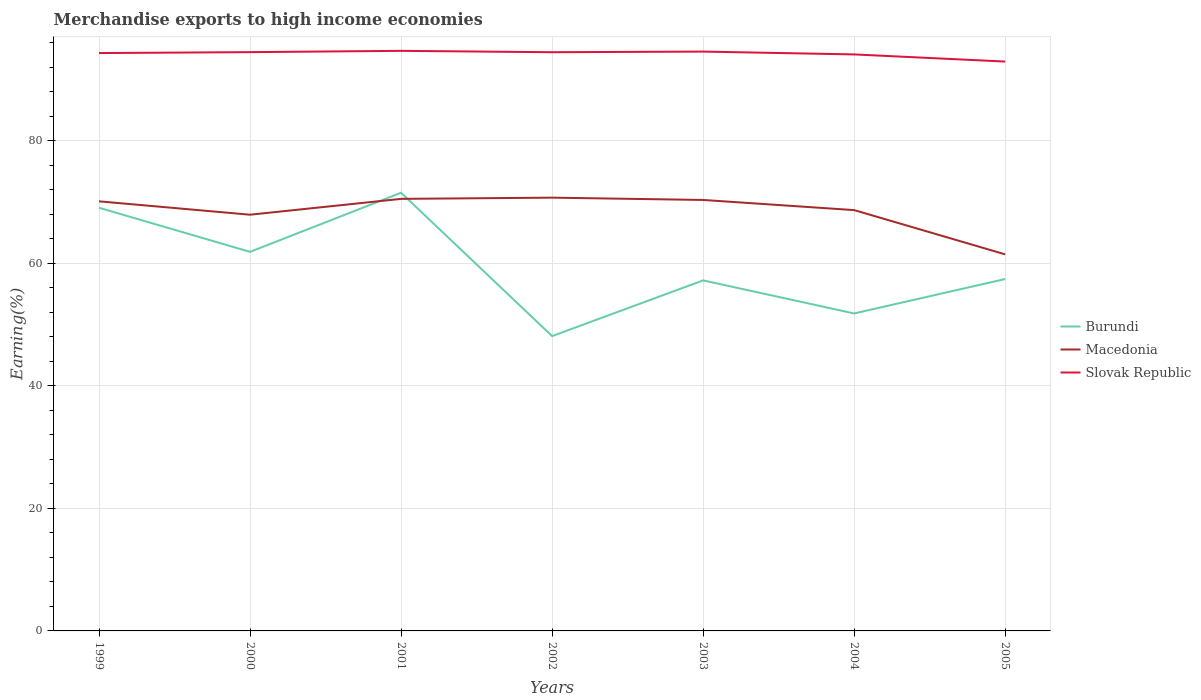Across all years, what is the maximum percentage of amount earned from merchandise exports in Macedonia?
Your answer should be very brief. 61.48. In which year was the percentage of amount earned from merchandise exports in Slovak Republic maximum?
Provide a short and direct response. 2005. What is the total percentage of amount earned from merchandise exports in Macedonia in the graph?
Offer a terse response. 1.43. What is the difference between the highest and the second highest percentage of amount earned from merchandise exports in Macedonia?
Keep it short and to the point. 9.26. What is the difference between two consecutive major ticks on the Y-axis?
Offer a terse response. 20. Does the graph contain grids?
Offer a terse response. Yes. How are the legend labels stacked?
Keep it short and to the point. Vertical. What is the title of the graph?
Give a very brief answer. Merchandise exports to high income economies. Does "Argentina" appear as one of the legend labels in the graph?
Make the answer very short. No. What is the label or title of the Y-axis?
Offer a very short reply. Earning(%). What is the Earning(%) in Burundi in 1999?
Offer a terse response. 69.09. What is the Earning(%) of Macedonia in 1999?
Ensure brevity in your answer.  70.14. What is the Earning(%) in Slovak Republic in 1999?
Make the answer very short. 94.35. What is the Earning(%) in Burundi in 2000?
Provide a succinct answer. 61.89. What is the Earning(%) of Macedonia in 2000?
Provide a succinct answer. 67.95. What is the Earning(%) of Slovak Republic in 2000?
Offer a terse response. 94.5. What is the Earning(%) of Burundi in 2001?
Provide a succinct answer. 71.54. What is the Earning(%) in Macedonia in 2001?
Make the answer very short. 70.54. What is the Earning(%) in Slovak Republic in 2001?
Make the answer very short. 94.71. What is the Earning(%) in Burundi in 2002?
Ensure brevity in your answer.  48.14. What is the Earning(%) in Macedonia in 2002?
Your response must be concise. 70.74. What is the Earning(%) in Slovak Republic in 2002?
Offer a very short reply. 94.48. What is the Earning(%) in Burundi in 2003?
Your answer should be very brief. 57.23. What is the Earning(%) of Macedonia in 2003?
Keep it short and to the point. 70.36. What is the Earning(%) of Slovak Republic in 2003?
Your answer should be very brief. 94.59. What is the Earning(%) of Burundi in 2004?
Your answer should be very brief. 51.83. What is the Earning(%) of Macedonia in 2004?
Ensure brevity in your answer.  68.71. What is the Earning(%) in Slovak Republic in 2004?
Give a very brief answer. 94.12. What is the Earning(%) of Burundi in 2005?
Offer a very short reply. 57.45. What is the Earning(%) of Macedonia in 2005?
Your response must be concise. 61.48. What is the Earning(%) in Slovak Republic in 2005?
Your answer should be very brief. 92.96. Across all years, what is the maximum Earning(%) of Burundi?
Keep it short and to the point. 71.54. Across all years, what is the maximum Earning(%) in Macedonia?
Keep it short and to the point. 70.74. Across all years, what is the maximum Earning(%) in Slovak Republic?
Your answer should be compact. 94.71. Across all years, what is the minimum Earning(%) of Burundi?
Offer a very short reply. 48.14. Across all years, what is the minimum Earning(%) of Macedonia?
Your answer should be compact. 61.48. Across all years, what is the minimum Earning(%) in Slovak Republic?
Your answer should be very brief. 92.96. What is the total Earning(%) in Burundi in the graph?
Provide a succinct answer. 417.17. What is the total Earning(%) in Macedonia in the graph?
Provide a short and direct response. 479.92. What is the total Earning(%) of Slovak Republic in the graph?
Your answer should be compact. 659.71. What is the difference between the Earning(%) of Burundi in 1999 and that in 2000?
Your answer should be very brief. 7.2. What is the difference between the Earning(%) in Macedonia in 1999 and that in 2000?
Your response must be concise. 2.19. What is the difference between the Earning(%) in Slovak Republic in 1999 and that in 2000?
Ensure brevity in your answer.  -0.15. What is the difference between the Earning(%) of Burundi in 1999 and that in 2001?
Your answer should be very brief. -2.45. What is the difference between the Earning(%) of Macedonia in 1999 and that in 2001?
Give a very brief answer. -0.4. What is the difference between the Earning(%) of Slovak Republic in 1999 and that in 2001?
Make the answer very short. -0.36. What is the difference between the Earning(%) of Burundi in 1999 and that in 2002?
Your answer should be very brief. 20.95. What is the difference between the Earning(%) in Macedonia in 1999 and that in 2002?
Provide a succinct answer. -0.6. What is the difference between the Earning(%) of Slovak Republic in 1999 and that in 2002?
Offer a very short reply. -0.14. What is the difference between the Earning(%) in Burundi in 1999 and that in 2003?
Give a very brief answer. 11.86. What is the difference between the Earning(%) of Macedonia in 1999 and that in 2003?
Provide a short and direct response. -0.22. What is the difference between the Earning(%) in Slovak Republic in 1999 and that in 2003?
Provide a succinct answer. -0.24. What is the difference between the Earning(%) of Burundi in 1999 and that in 2004?
Ensure brevity in your answer.  17.26. What is the difference between the Earning(%) of Macedonia in 1999 and that in 2004?
Offer a terse response. 1.43. What is the difference between the Earning(%) of Slovak Republic in 1999 and that in 2004?
Give a very brief answer. 0.22. What is the difference between the Earning(%) of Burundi in 1999 and that in 2005?
Offer a very short reply. 11.64. What is the difference between the Earning(%) of Macedonia in 1999 and that in 2005?
Provide a short and direct response. 8.66. What is the difference between the Earning(%) of Slovak Republic in 1999 and that in 2005?
Your answer should be compact. 1.39. What is the difference between the Earning(%) of Burundi in 2000 and that in 2001?
Your response must be concise. -9.65. What is the difference between the Earning(%) of Macedonia in 2000 and that in 2001?
Provide a succinct answer. -2.59. What is the difference between the Earning(%) in Slovak Republic in 2000 and that in 2001?
Your answer should be very brief. -0.21. What is the difference between the Earning(%) of Burundi in 2000 and that in 2002?
Provide a short and direct response. 13.76. What is the difference between the Earning(%) of Macedonia in 2000 and that in 2002?
Provide a short and direct response. -2.78. What is the difference between the Earning(%) in Slovak Republic in 2000 and that in 2002?
Give a very brief answer. 0.01. What is the difference between the Earning(%) in Burundi in 2000 and that in 2003?
Provide a short and direct response. 4.66. What is the difference between the Earning(%) in Macedonia in 2000 and that in 2003?
Offer a very short reply. -2.41. What is the difference between the Earning(%) of Slovak Republic in 2000 and that in 2003?
Make the answer very short. -0.09. What is the difference between the Earning(%) of Burundi in 2000 and that in 2004?
Your response must be concise. 10.06. What is the difference between the Earning(%) in Macedonia in 2000 and that in 2004?
Keep it short and to the point. -0.75. What is the difference between the Earning(%) in Slovak Republic in 2000 and that in 2004?
Keep it short and to the point. 0.37. What is the difference between the Earning(%) in Burundi in 2000 and that in 2005?
Your response must be concise. 4.44. What is the difference between the Earning(%) in Macedonia in 2000 and that in 2005?
Your answer should be very brief. 6.48. What is the difference between the Earning(%) in Slovak Republic in 2000 and that in 2005?
Provide a succinct answer. 1.54. What is the difference between the Earning(%) in Burundi in 2001 and that in 2002?
Give a very brief answer. 23.4. What is the difference between the Earning(%) of Macedonia in 2001 and that in 2002?
Offer a very short reply. -0.2. What is the difference between the Earning(%) in Slovak Republic in 2001 and that in 2002?
Your response must be concise. 0.23. What is the difference between the Earning(%) of Burundi in 2001 and that in 2003?
Keep it short and to the point. 14.31. What is the difference between the Earning(%) in Macedonia in 2001 and that in 2003?
Offer a very short reply. 0.18. What is the difference between the Earning(%) of Slovak Republic in 2001 and that in 2003?
Your response must be concise. 0.12. What is the difference between the Earning(%) of Burundi in 2001 and that in 2004?
Make the answer very short. 19.7. What is the difference between the Earning(%) in Macedonia in 2001 and that in 2004?
Give a very brief answer. 1.84. What is the difference between the Earning(%) in Slovak Republic in 2001 and that in 2004?
Provide a short and direct response. 0.59. What is the difference between the Earning(%) in Burundi in 2001 and that in 2005?
Provide a succinct answer. 14.08. What is the difference between the Earning(%) of Macedonia in 2001 and that in 2005?
Ensure brevity in your answer.  9.06. What is the difference between the Earning(%) in Slovak Republic in 2001 and that in 2005?
Give a very brief answer. 1.75. What is the difference between the Earning(%) in Burundi in 2002 and that in 2003?
Your answer should be compact. -9.09. What is the difference between the Earning(%) of Macedonia in 2002 and that in 2003?
Ensure brevity in your answer.  0.38. What is the difference between the Earning(%) of Slovak Republic in 2002 and that in 2003?
Provide a short and direct response. -0.1. What is the difference between the Earning(%) in Burundi in 2002 and that in 2004?
Offer a terse response. -3.7. What is the difference between the Earning(%) of Macedonia in 2002 and that in 2004?
Offer a terse response. 2.03. What is the difference between the Earning(%) of Slovak Republic in 2002 and that in 2004?
Offer a very short reply. 0.36. What is the difference between the Earning(%) of Burundi in 2002 and that in 2005?
Your response must be concise. -9.32. What is the difference between the Earning(%) of Macedonia in 2002 and that in 2005?
Offer a terse response. 9.26. What is the difference between the Earning(%) of Slovak Republic in 2002 and that in 2005?
Provide a succinct answer. 1.53. What is the difference between the Earning(%) in Burundi in 2003 and that in 2004?
Make the answer very short. 5.4. What is the difference between the Earning(%) in Macedonia in 2003 and that in 2004?
Provide a succinct answer. 1.66. What is the difference between the Earning(%) of Slovak Republic in 2003 and that in 2004?
Offer a very short reply. 0.46. What is the difference between the Earning(%) of Burundi in 2003 and that in 2005?
Provide a succinct answer. -0.22. What is the difference between the Earning(%) of Macedonia in 2003 and that in 2005?
Provide a succinct answer. 8.88. What is the difference between the Earning(%) in Slovak Republic in 2003 and that in 2005?
Ensure brevity in your answer.  1.63. What is the difference between the Earning(%) of Burundi in 2004 and that in 2005?
Offer a terse response. -5.62. What is the difference between the Earning(%) in Macedonia in 2004 and that in 2005?
Your answer should be very brief. 7.23. What is the difference between the Earning(%) of Slovak Republic in 2004 and that in 2005?
Ensure brevity in your answer.  1.17. What is the difference between the Earning(%) of Burundi in 1999 and the Earning(%) of Macedonia in 2000?
Provide a short and direct response. 1.14. What is the difference between the Earning(%) in Burundi in 1999 and the Earning(%) in Slovak Republic in 2000?
Offer a terse response. -25.41. What is the difference between the Earning(%) of Macedonia in 1999 and the Earning(%) of Slovak Republic in 2000?
Ensure brevity in your answer.  -24.36. What is the difference between the Earning(%) in Burundi in 1999 and the Earning(%) in Macedonia in 2001?
Make the answer very short. -1.45. What is the difference between the Earning(%) of Burundi in 1999 and the Earning(%) of Slovak Republic in 2001?
Offer a terse response. -25.62. What is the difference between the Earning(%) of Macedonia in 1999 and the Earning(%) of Slovak Republic in 2001?
Keep it short and to the point. -24.57. What is the difference between the Earning(%) of Burundi in 1999 and the Earning(%) of Macedonia in 2002?
Ensure brevity in your answer.  -1.65. What is the difference between the Earning(%) in Burundi in 1999 and the Earning(%) in Slovak Republic in 2002?
Give a very brief answer. -25.39. What is the difference between the Earning(%) of Macedonia in 1999 and the Earning(%) of Slovak Republic in 2002?
Your answer should be compact. -24.34. What is the difference between the Earning(%) in Burundi in 1999 and the Earning(%) in Macedonia in 2003?
Your response must be concise. -1.27. What is the difference between the Earning(%) in Burundi in 1999 and the Earning(%) in Slovak Republic in 2003?
Offer a very short reply. -25.5. What is the difference between the Earning(%) of Macedonia in 1999 and the Earning(%) of Slovak Republic in 2003?
Keep it short and to the point. -24.45. What is the difference between the Earning(%) of Burundi in 1999 and the Earning(%) of Macedonia in 2004?
Offer a terse response. 0.38. What is the difference between the Earning(%) of Burundi in 1999 and the Earning(%) of Slovak Republic in 2004?
Provide a succinct answer. -25.03. What is the difference between the Earning(%) in Macedonia in 1999 and the Earning(%) in Slovak Republic in 2004?
Your answer should be compact. -23.98. What is the difference between the Earning(%) in Burundi in 1999 and the Earning(%) in Macedonia in 2005?
Offer a terse response. 7.61. What is the difference between the Earning(%) in Burundi in 1999 and the Earning(%) in Slovak Republic in 2005?
Make the answer very short. -23.87. What is the difference between the Earning(%) of Macedonia in 1999 and the Earning(%) of Slovak Republic in 2005?
Provide a succinct answer. -22.82. What is the difference between the Earning(%) of Burundi in 2000 and the Earning(%) of Macedonia in 2001?
Give a very brief answer. -8.65. What is the difference between the Earning(%) of Burundi in 2000 and the Earning(%) of Slovak Republic in 2001?
Your answer should be compact. -32.82. What is the difference between the Earning(%) of Macedonia in 2000 and the Earning(%) of Slovak Republic in 2001?
Offer a terse response. -26.75. What is the difference between the Earning(%) of Burundi in 2000 and the Earning(%) of Macedonia in 2002?
Ensure brevity in your answer.  -8.85. What is the difference between the Earning(%) of Burundi in 2000 and the Earning(%) of Slovak Republic in 2002?
Your answer should be very brief. -32.59. What is the difference between the Earning(%) in Macedonia in 2000 and the Earning(%) in Slovak Republic in 2002?
Ensure brevity in your answer.  -26.53. What is the difference between the Earning(%) of Burundi in 2000 and the Earning(%) of Macedonia in 2003?
Make the answer very short. -8.47. What is the difference between the Earning(%) in Burundi in 2000 and the Earning(%) in Slovak Republic in 2003?
Your answer should be compact. -32.7. What is the difference between the Earning(%) in Macedonia in 2000 and the Earning(%) in Slovak Republic in 2003?
Make the answer very short. -26.63. What is the difference between the Earning(%) of Burundi in 2000 and the Earning(%) of Macedonia in 2004?
Offer a very short reply. -6.82. What is the difference between the Earning(%) in Burundi in 2000 and the Earning(%) in Slovak Republic in 2004?
Ensure brevity in your answer.  -32.23. What is the difference between the Earning(%) of Macedonia in 2000 and the Earning(%) of Slovak Republic in 2004?
Your answer should be compact. -26.17. What is the difference between the Earning(%) of Burundi in 2000 and the Earning(%) of Macedonia in 2005?
Offer a very short reply. 0.41. What is the difference between the Earning(%) of Burundi in 2000 and the Earning(%) of Slovak Republic in 2005?
Ensure brevity in your answer.  -31.07. What is the difference between the Earning(%) in Macedonia in 2000 and the Earning(%) in Slovak Republic in 2005?
Your response must be concise. -25. What is the difference between the Earning(%) in Burundi in 2001 and the Earning(%) in Macedonia in 2002?
Offer a terse response. 0.8. What is the difference between the Earning(%) in Burundi in 2001 and the Earning(%) in Slovak Republic in 2002?
Provide a short and direct response. -22.95. What is the difference between the Earning(%) of Macedonia in 2001 and the Earning(%) of Slovak Republic in 2002?
Your response must be concise. -23.94. What is the difference between the Earning(%) in Burundi in 2001 and the Earning(%) in Macedonia in 2003?
Your answer should be compact. 1.17. What is the difference between the Earning(%) in Burundi in 2001 and the Earning(%) in Slovak Republic in 2003?
Ensure brevity in your answer.  -23.05. What is the difference between the Earning(%) of Macedonia in 2001 and the Earning(%) of Slovak Republic in 2003?
Keep it short and to the point. -24.05. What is the difference between the Earning(%) of Burundi in 2001 and the Earning(%) of Macedonia in 2004?
Offer a terse response. 2.83. What is the difference between the Earning(%) of Burundi in 2001 and the Earning(%) of Slovak Republic in 2004?
Your response must be concise. -22.59. What is the difference between the Earning(%) in Macedonia in 2001 and the Earning(%) in Slovak Republic in 2004?
Your answer should be very brief. -23.58. What is the difference between the Earning(%) in Burundi in 2001 and the Earning(%) in Macedonia in 2005?
Keep it short and to the point. 10.06. What is the difference between the Earning(%) of Burundi in 2001 and the Earning(%) of Slovak Republic in 2005?
Provide a short and direct response. -21.42. What is the difference between the Earning(%) of Macedonia in 2001 and the Earning(%) of Slovak Republic in 2005?
Provide a succinct answer. -22.42. What is the difference between the Earning(%) in Burundi in 2002 and the Earning(%) in Macedonia in 2003?
Offer a very short reply. -22.23. What is the difference between the Earning(%) in Burundi in 2002 and the Earning(%) in Slovak Republic in 2003?
Give a very brief answer. -46.45. What is the difference between the Earning(%) of Macedonia in 2002 and the Earning(%) of Slovak Republic in 2003?
Your answer should be compact. -23.85. What is the difference between the Earning(%) of Burundi in 2002 and the Earning(%) of Macedonia in 2004?
Provide a short and direct response. -20.57. What is the difference between the Earning(%) of Burundi in 2002 and the Earning(%) of Slovak Republic in 2004?
Your response must be concise. -45.99. What is the difference between the Earning(%) of Macedonia in 2002 and the Earning(%) of Slovak Republic in 2004?
Your response must be concise. -23.39. What is the difference between the Earning(%) in Burundi in 2002 and the Earning(%) in Macedonia in 2005?
Make the answer very short. -13.34. What is the difference between the Earning(%) in Burundi in 2002 and the Earning(%) in Slovak Republic in 2005?
Offer a very short reply. -44.82. What is the difference between the Earning(%) in Macedonia in 2002 and the Earning(%) in Slovak Republic in 2005?
Offer a terse response. -22.22. What is the difference between the Earning(%) of Burundi in 2003 and the Earning(%) of Macedonia in 2004?
Keep it short and to the point. -11.48. What is the difference between the Earning(%) of Burundi in 2003 and the Earning(%) of Slovak Republic in 2004?
Give a very brief answer. -36.89. What is the difference between the Earning(%) of Macedonia in 2003 and the Earning(%) of Slovak Republic in 2004?
Provide a short and direct response. -23.76. What is the difference between the Earning(%) of Burundi in 2003 and the Earning(%) of Macedonia in 2005?
Provide a succinct answer. -4.25. What is the difference between the Earning(%) in Burundi in 2003 and the Earning(%) in Slovak Republic in 2005?
Provide a short and direct response. -35.73. What is the difference between the Earning(%) in Macedonia in 2003 and the Earning(%) in Slovak Republic in 2005?
Make the answer very short. -22.59. What is the difference between the Earning(%) in Burundi in 2004 and the Earning(%) in Macedonia in 2005?
Offer a terse response. -9.65. What is the difference between the Earning(%) in Burundi in 2004 and the Earning(%) in Slovak Republic in 2005?
Offer a terse response. -41.13. What is the difference between the Earning(%) in Macedonia in 2004 and the Earning(%) in Slovak Republic in 2005?
Give a very brief answer. -24.25. What is the average Earning(%) in Burundi per year?
Provide a short and direct response. 59.6. What is the average Earning(%) in Macedonia per year?
Your answer should be very brief. 68.56. What is the average Earning(%) of Slovak Republic per year?
Make the answer very short. 94.24. In the year 1999, what is the difference between the Earning(%) of Burundi and Earning(%) of Macedonia?
Provide a succinct answer. -1.05. In the year 1999, what is the difference between the Earning(%) in Burundi and Earning(%) in Slovak Republic?
Offer a terse response. -25.25. In the year 1999, what is the difference between the Earning(%) of Macedonia and Earning(%) of Slovak Republic?
Provide a succinct answer. -24.21. In the year 2000, what is the difference between the Earning(%) in Burundi and Earning(%) in Macedonia?
Ensure brevity in your answer.  -6.06. In the year 2000, what is the difference between the Earning(%) in Burundi and Earning(%) in Slovak Republic?
Your response must be concise. -32.61. In the year 2000, what is the difference between the Earning(%) of Macedonia and Earning(%) of Slovak Republic?
Provide a succinct answer. -26.54. In the year 2001, what is the difference between the Earning(%) of Burundi and Earning(%) of Slovak Republic?
Your answer should be compact. -23.17. In the year 2001, what is the difference between the Earning(%) of Macedonia and Earning(%) of Slovak Republic?
Ensure brevity in your answer.  -24.17. In the year 2002, what is the difference between the Earning(%) of Burundi and Earning(%) of Macedonia?
Provide a short and direct response. -22.6. In the year 2002, what is the difference between the Earning(%) in Burundi and Earning(%) in Slovak Republic?
Provide a succinct answer. -46.35. In the year 2002, what is the difference between the Earning(%) of Macedonia and Earning(%) of Slovak Republic?
Make the answer very short. -23.75. In the year 2003, what is the difference between the Earning(%) in Burundi and Earning(%) in Macedonia?
Make the answer very short. -13.13. In the year 2003, what is the difference between the Earning(%) of Burundi and Earning(%) of Slovak Republic?
Provide a succinct answer. -37.36. In the year 2003, what is the difference between the Earning(%) in Macedonia and Earning(%) in Slovak Republic?
Ensure brevity in your answer.  -24.22. In the year 2004, what is the difference between the Earning(%) in Burundi and Earning(%) in Macedonia?
Provide a succinct answer. -16.87. In the year 2004, what is the difference between the Earning(%) of Burundi and Earning(%) of Slovak Republic?
Provide a short and direct response. -42.29. In the year 2004, what is the difference between the Earning(%) of Macedonia and Earning(%) of Slovak Republic?
Offer a terse response. -25.42. In the year 2005, what is the difference between the Earning(%) in Burundi and Earning(%) in Macedonia?
Ensure brevity in your answer.  -4.02. In the year 2005, what is the difference between the Earning(%) of Burundi and Earning(%) of Slovak Republic?
Provide a short and direct response. -35.5. In the year 2005, what is the difference between the Earning(%) in Macedonia and Earning(%) in Slovak Republic?
Your answer should be compact. -31.48. What is the ratio of the Earning(%) in Burundi in 1999 to that in 2000?
Your answer should be compact. 1.12. What is the ratio of the Earning(%) of Macedonia in 1999 to that in 2000?
Provide a succinct answer. 1.03. What is the ratio of the Earning(%) of Slovak Republic in 1999 to that in 2000?
Give a very brief answer. 1. What is the ratio of the Earning(%) of Burundi in 1999 to that in 2001?
Give a very brief answer. 0.97. What is the ratio of the Earning(%) in Slovak Republic in 1999 to that in 2001?
Your answer should be very brief. 1. What is the ratio of the Earning(%) of Burundi in 1999 to that in 2002?
Ensure brevity in your answer.  1.44. What is the ratio of the Earning(%) of Slovak Republic in 1999 to that in 2002?
Keep it short and to the point. 1. What is the ratio of the Earning(%) of Burundi in 1999 to that in 2003?
Offer a very short reply. 1.21. What is the ratio of the Earning(%) of Macedonia in 1999 to that in 2003?
Your response must be concise. 1. What is the ratio of the Earning(%) of Burundi in 1999 to that in 2004?
Make the answer very short. 1.33. What is the ratio of the Earning(%) of Macedonia in 1999 to that in 2004?
Offer a terse response. 1.02. What is the ratio of the Earning(%) in Slovak Republic in 1999 to that in 2004?
Your answer should be very brief. 1. What is the ratio of the Earning(%) in Burundi in 1999 to that in 2005?
Give a very brief answer. 1.2. What is the ratio of the Earning(%) in Macedonia in 1999 to that in 2005?
Your answer should be very brief. 1.14. What is the ratio of the Earning(%) in Slovak Republic in 1999 to that in 2005?
Make the answer very short. 1.01. What is the ratio of the Earning(%) in Burundi in 2000 to that in 2001?
Offer a very short reply. 0.87. What is the ratio of the Earning(%) of Macedonia in 2000 to that in 2001?
Offer a very short reply. 0.96. What is the ratio of the Earning(%) of Burundi in 2000 to that in 2002?
Provide a succinct answer. 1.29. What is the ratio of the Earning(%) in Macedonia in 2000 to that in 2002?
Provide a short and direct response. 0.96. What is the ratio of the Earning(%) in Slovak Republic in 2000 to that in 2002?
Give a very brief answer. 1. What is the ratio of the Earning(%) in Burundi in 2000 to that in 2003?
Ensure brevity in your answer.  1.08. What is the ratio of the Earning(%) in Macedonia in 2000 to that in 2003?
Keep it short and to the point. 0.97. What is the ratio of the Earning(%) of Slovak Republic in 2000 to that in 2003?
Your answer should be compact. 1. What is the ratio of the Earning(%) in Burundi in 2000 to that in 2004?
Your answer should be very brief. 1.19. What is the ratio of the Earning(%) of Macedonia in 2000 to that in 2004?
Provide a short and direct response. 0.99. What is the ratio of the Earning(%) in Slovak Republic in 2000 to that in 2004?
Ensure brevity in your answer.  1. What is the ratio of the Earning(%) in Burundi in 2000 to that in 2005?
Offer a very short reply. 1.08. What is the ratio of the Earning(%) in Macedonia in 2000 to that in 2005?
Provide a succinct answer. 1.11. What is the ratio of the Earning(%) in Slovak Republic in 2000 to that in 2005?
Offer a very short reply. 1.02. What is the ratio of the Earning(%) in Burundi in 2001 to that in 2002?
Offer a terse response. 1.49. What is the ratio of the Earning(%) in Macedonia in 2001 to that in 2002?
Your response must be concise. 1. What is the ratio of the Earning(%) of Macedonia in 2001 to that in 2003?
Provide a short and direct response. 1. What is the ratio of the Earning(%) in Burundi in 2001 to that in 2004?
Ensure brevity in your answer.  1.38. What is the ratio of the Earning(%) of Macedonia in 2001 to that in 2004?
Provide a short and direct response. 1.03. What is the ratio of the Earning(%) of Slovak Republic in 2001 to that in 2004?
Make the answer very short. 1.01. What is the ratio of the Earning(%) of Burundi in 2001 to that in 2005?
Your answer should be very brief. 1.25. What is the ratio of the Earning(%) in Macedonia in 2001 to that in 2005?
Keep it short and to the point. 1.15. What is the ratio of the Earning(%) in Slovak Republic in 2001 to that in 2005?
Provide a short and direct response. 1.02. What is the ratio of the Earning(%) of Burundi in 2002 to that in 2003?
Give a very brief answer. 0.84. What is the ratio of the Earning(%) of Burundi in 2002 to that in 2004?
Your answer should be very brief. 0.93. What is the ratio of the Earning(%) in Macedonia in 2002 to that in 2004?
Offer a very short reply. 1.03. What is the ratio of the Earning(%) in Slovak Republic in 2002 to that in 2004?
Your answer should be very brief. 1. What is the ratio of the Earning(%) of Burundi in 2002 to that in 2005?
Your response must be concise. 0.84. What is the ratio of the Earning(%) of Macedonia in 2002 to that in 2005?
Ensure brevity in your answer.  1.15. What is the ratio of the Earning(%) of Slovak Republic in 2002 to that in 2005?
Provide a succinct answer. 1.02. What is the ratio of the Earning(%) of Burundi in 2003 to that in 2004?
Provide a succinct answer. 1.1. What is the ratio of the Earning(%) of Macedonia in 2003 to that in 2004?
Your response must be concise. 1.02. What is the ratio of the Earning(%) in Slovak Republic in 2003 to that in 2004?
Give a very brief answer. 1. What is the ratio of the Earning(%) in Macedonia in 2003 to that in 2005?
Offer a very short reply. 1.14. What is the ratio of the Earning(%) in Slovak Republic in 2003 to that in 2005?
Offer a terse response. 1.02. What is the ratio of the Earning(%) in Burundi in 2004 to that in 2005?
Ensure brevity in your answer.  0.9. What is the ratio of the Earning(%) of Macedonia in 2004 to that in 2005?
Provide a short and direct response. 1.12. What is the ratio of the Earning(%) in Slovak Republic in 2004 to that in 2005?
Offer a very short reply. 1.01. What is the difference between the highest and the second highest Earning(%) in Burundi?
Give a very brief answer. 2.45. What is the difference between the highest and the second highest Earning(%) of Macedonia?
Provide a short and direct response. 0.2. What is the difference between the highest and the second highest Earning(%) in Slovak Republic?
Your answer should be compact. 0.12. What is the difference between the highest and the lowest Earning(%) in Burundi?
Give a very brief answer. 23.4. What is the difference between the highest and the lowest Earning(%) in Macedonia?
Provide a short and direct response. 9.26. What is the difference between the highest and the lowest Earning(%) in Slovak Republic?
Your answer should be very brief. 1.75. 